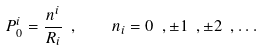<formula> <loc_0><loc_0><loc_500><loc_500>P ^ { i } _ { 0 } = \frac { n ^ { i } } { R _ { i } } \ , \quad n _ { i } = 0 \ , \pm 1 \ , \pm 2 \ , \dots</formula> 